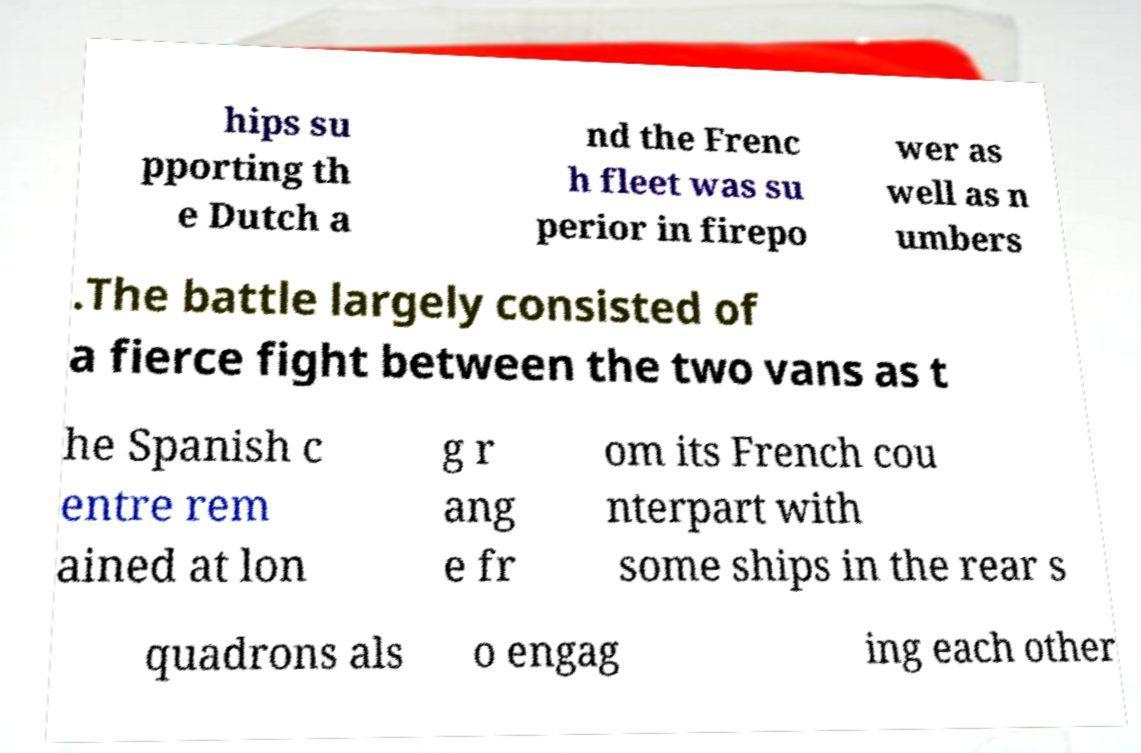Please read and relay the text visible in this image. What does it say? hips su pporting th e Dutch a nd the Frenc h fleet was su perior in firepo wer as well as n umbers .The battle largely consisted of a fierce fight between the two vans as t he Spanish c entre rem ained at lon g r ang e fr om its French cou nterpart with some ships in the rear s quadrons als o engag ing each other 